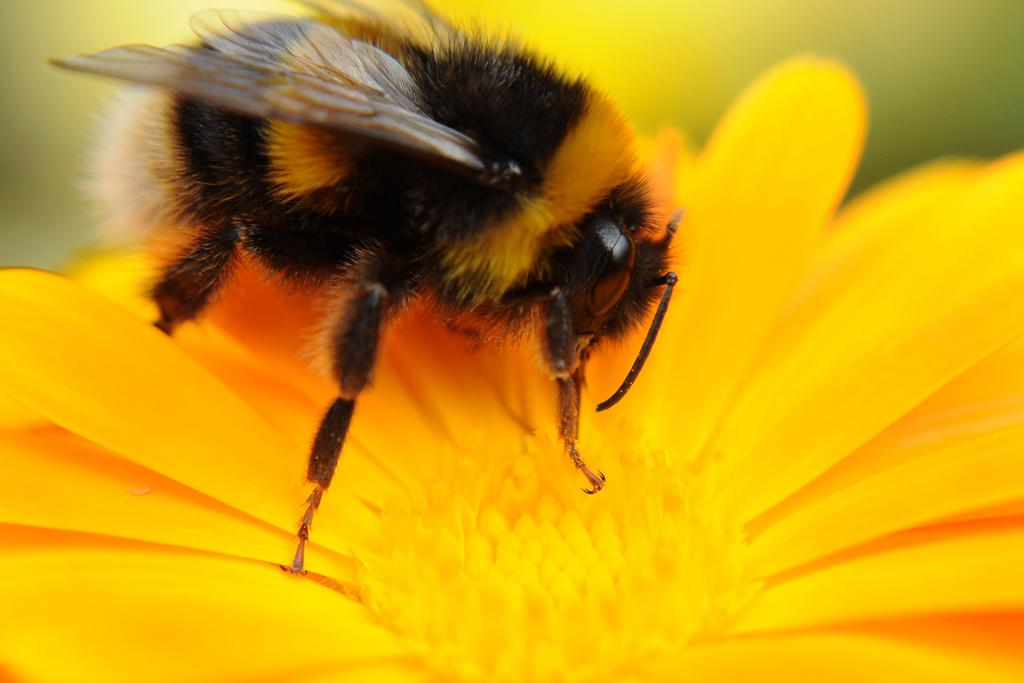What type of insect is in the image? There is a honey bee in the image. Where is the honey bee located in the image? The honey bee is on a flower. What type of whip is the honey bee using to fly in the image? There is no whip present in the image, and honey bees do not use whips to fly. 